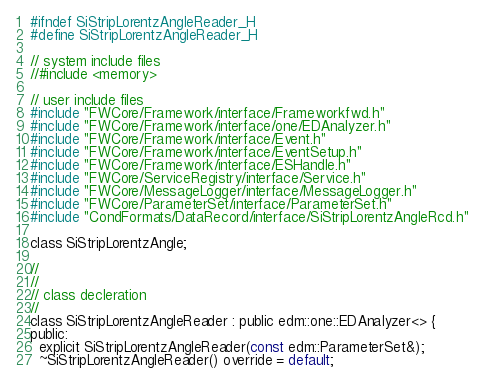<code> <loc_0><loc_0><loc_500><loc_500><_C_>#ifndef SiStripLorentzAngleReader_H
#define SiStripLorentzAngleReader_H

// system include files
//#include <memory>

// user include files
#include "FWCore/Framework/interface/Frameworkfwd.h"
#include "FWCore/Framework/interface/one/EDAnalyzer.h"
#include "FWCore/Framework/interface/Event.h"
#include "FWCore/Framework/interface/EventSetup.h"
#include "FWCore/Framework/interface/ESHandle.h"
#include "FWCore/ServiceRegistry/interface/Service.h"
#include "FWCore/MessageLogger/interface/MessageLogger.h"
#include "FWCore/ParameterSet/interface/ParameterSet.h"
#include "CondFormats/DataRecord/interface/SiStripLorentzAngleRcd.h"

class SiStripLorentzAngle;

//
//
// class decleration
//
class SiStripLorentzAngleReader : public edm::one::EDAnalyzer<> {
public:
  explicit SiStripLorentzAngleReader(const edm::ParameterSet&);
  ~SiStripLorentzAngleReader() override = default;
</code> 